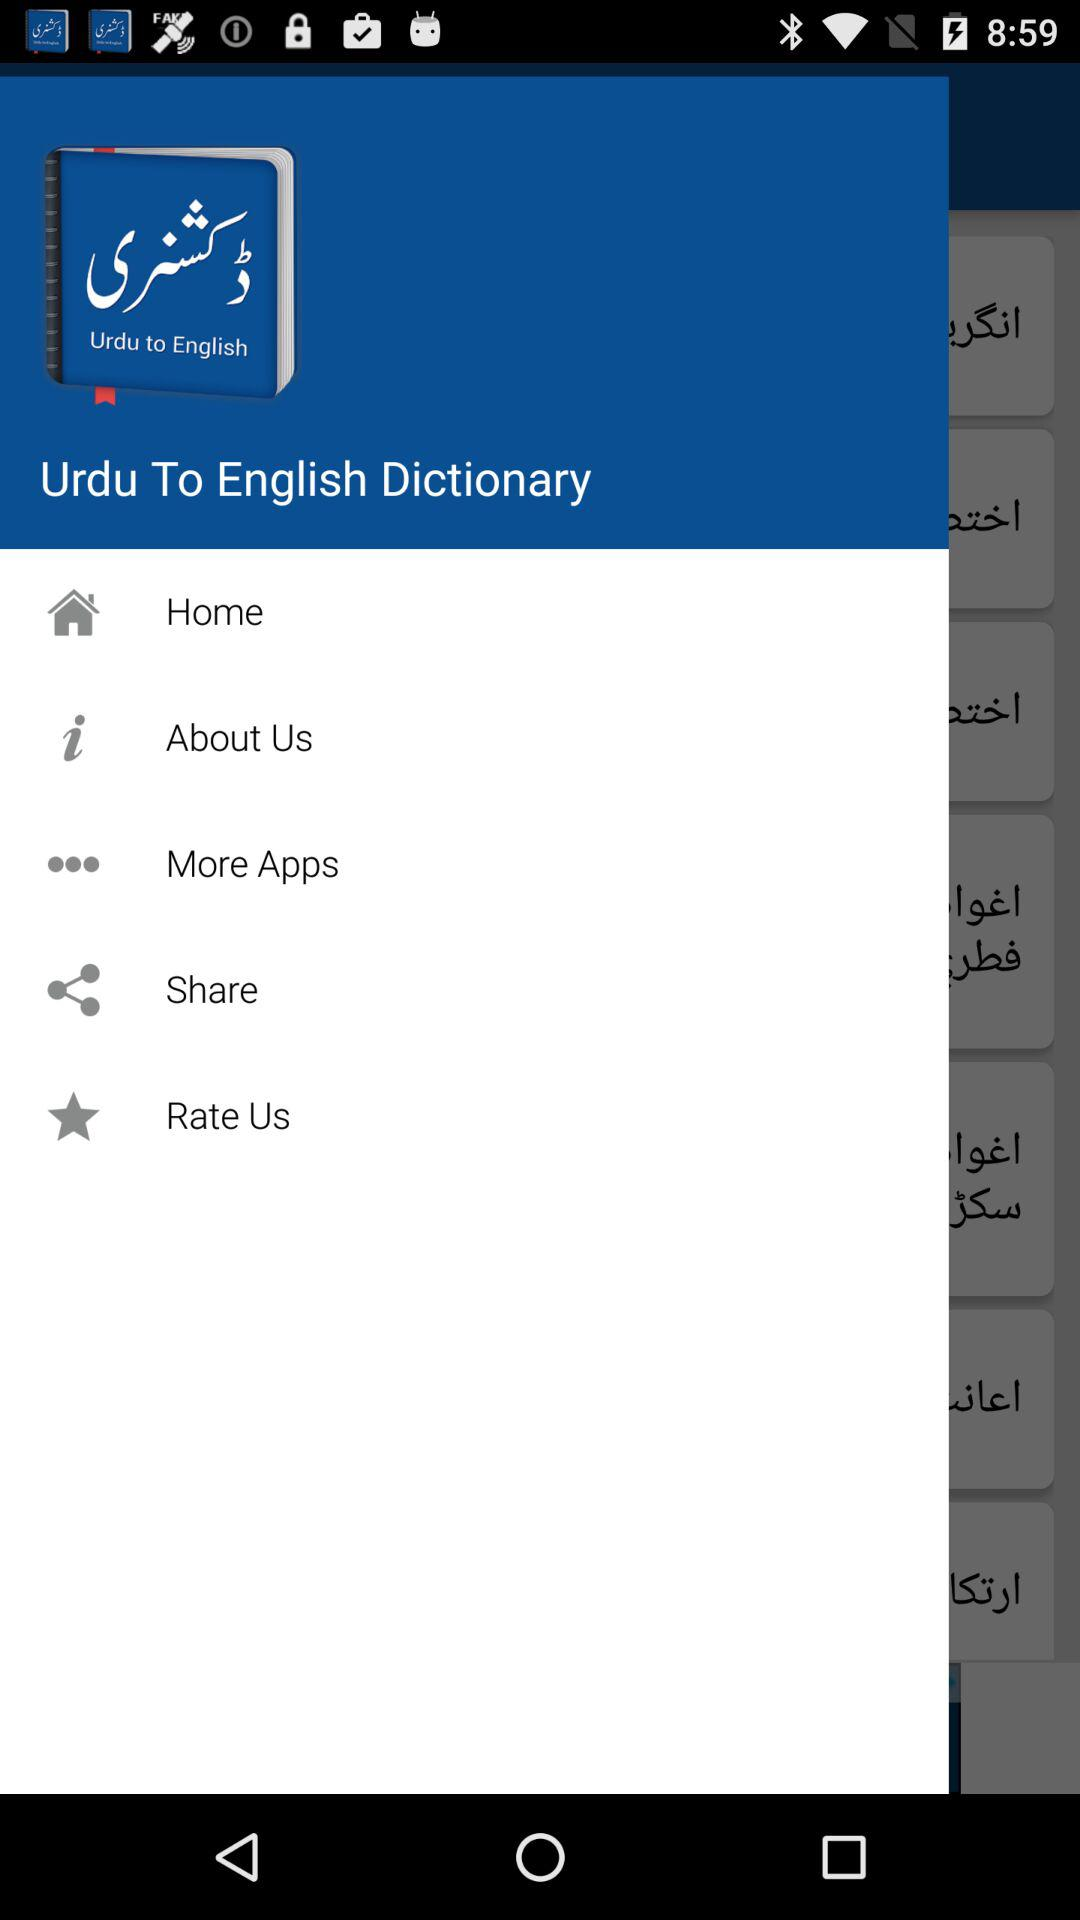Which language does it translate to? It is translated into English. 